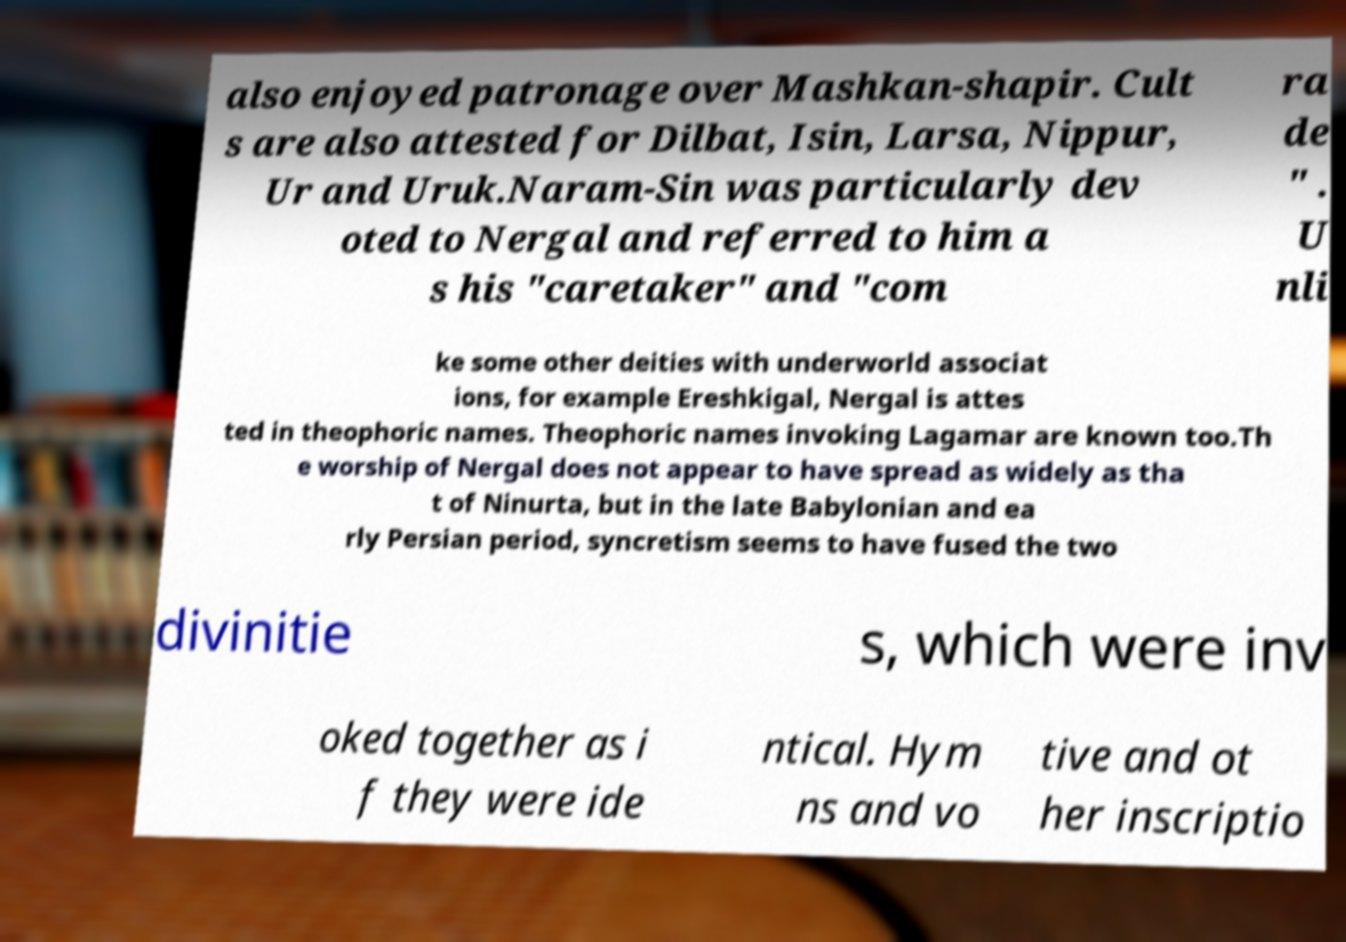Could you extract and type out the text from this image? also enjoyed patronage over Mashkan-shapir. Cult s are also attested for Dilbat, Isin, Larsa, Nippur, Ur and Uruk.Naram-Sin was particularly dev oted to Nergal and referred to him a s his "caretaker" and "com ra de " . U nli ke some other deities with underworld associat ions, for example Ereshkigal, Nergal is attes ted in theophoric names. Theophoric names invoking Lagamar are known too.Th e worship of Nergal does not appear to have spread as widely as tha t of Ninurta, but in the late Babylonian and ea rly Persian period, syncretism seems to have fused the two divinitie s, which were inv oked together as i f they were ide ntical. Hym ns and vo tive and ot her inscriptio 